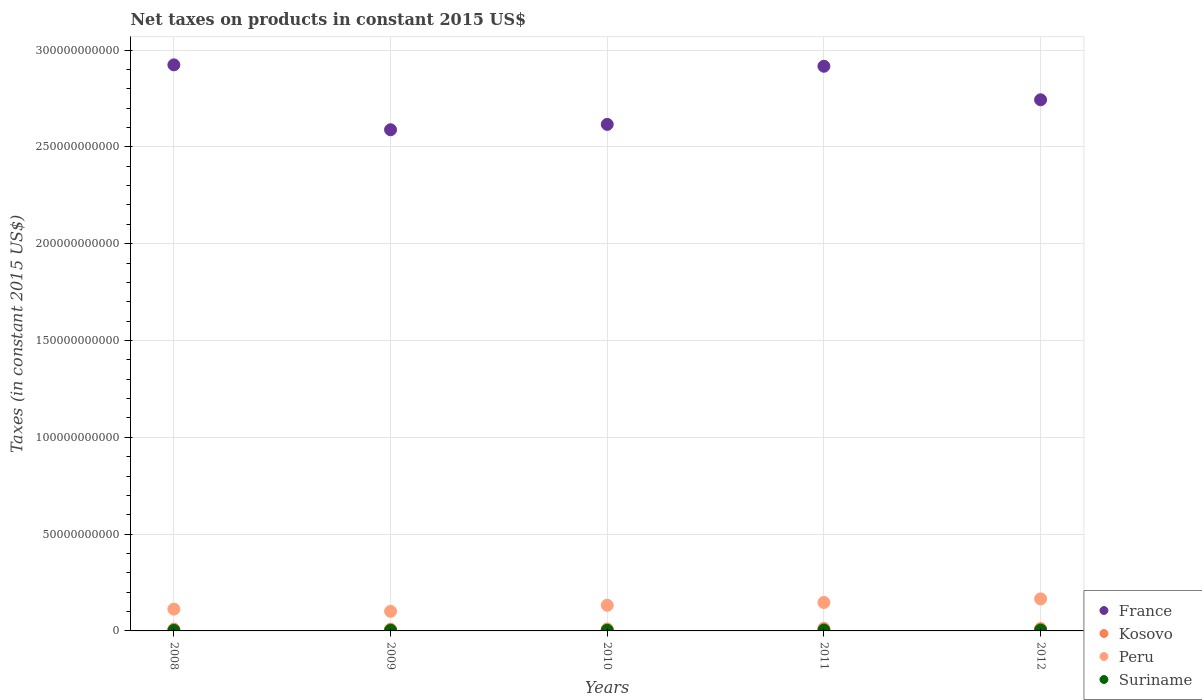How many different coloured dotlines are there?
Your answer should be compact. 4. Is the number of dotlines equal to the number of legend labels?
Your answer should be very brief. Yes. What is the net taxes on products in Kosovo in 2008?
Give a very brief answer. 8.66e+08. Across all years, what is the maximum net taxes on products in France?
Offer a very short reply. 2.92e+11. Across all years, what is the minimum net taxes on products in Kosovo?
Offer a very short reply. 8.48e+08. In which year was the net taxes on products in Peru maximum?
Provide a succinct answer. 2012. What is the total net taxes on products in Kosovo in the graph?
Your response must be concise. 5.02e+09. What is the difference between the net taxes on products in Suriname in 2010 and that in 2011?
Ensure brevity in your answer.  -9.22e+07. What is the difference between the net taxes on products in Peru in 2012 and the net taxes on products in France in 2009?
Ensure brevity in your answer.  -2.42e+11. What is the average net taxes on products in Suriname per year?
Your answer should be very brief. 3.41e+08. In the year 2012, what is the difference between the net taxes on products in Suriname and net taxes on products in Peru?
Provide a short and direct response. -1.61e+1. In how many years, is the net taxes on products in Peru greater than 130000000000 US$?
Offer a very short reply. 0. What is the ratio of the net taxes on products in Kosovo in 2008 to that in 2011?
Offer a terse response. 0.72. Is the net taxes on products in Suriname in 2009 less than that in 2011?
Make the answer very short. Yes. What is the difference between the highest and the second highest net taxes on products in Kosovo?
Ensure brevity in your answer.  6.31e+07. What is the difference between the highest and the lowest net taxes on products in Peru?
Offer a terse response. 6.41e+09. Is it the case that in every year, the sum of the net taxes on products in Peru and net taxes on products in France  is greater than the sum of net taxes on products in Suriname and net taxes on products in Kosovo?
Offer a terse response. Yes. Is it the case that in every year, the sum of the net taxes on products in Suriname and net taxes on products in Kosovo  is greater than the net taxes on products in Peru?
Provide a short and direct response. No. How many dotlines are there?
Your response must be concise. 4. How many years are there in the graph?
Offer a very short reply. 5. Does the graph contain any zero values?
Make the answer very short. No. What is the title of the graph?
Ensure brevity in your answer.  Net taxes on products in constant 2015 US$. Does "Guam" appear as one of the legend labels in the graph?
Ensure brevity in your answer.  No. What is the label or title of the Y-axis?
Your answer should be very brief. Taxes (in constant 2015 US$). What is the Taxes (in constant 2015 US$) in France in 2008?
Ensure brevity in your answer.  2.92e+11. What is the Taxes (in constant 2015 US$) in Kosovo in 2008?
Give a very brief answer. 8.66e+08. What is the Taxes (in constant 2015 US$) in Peru in 2008?
Give a very brief answer. 1.13e+1. What is the Taxes (in constant 2015 US$) in Suriname in 2008?
Provide a succinct answer. 2.41e+08. What is the Taxes (in constant 2015 US$) of France in 2009?
Ensure brevity in your answer.  2.59e+11. What is the Taxes (in constant 2015 US$) of Kosovo in 2009?
Provide a succinct answer. 8.48e+08. What is the Taxes (in constant 2015 US$) in Peru in 2009?
Give a very brief answer. 1.01e+1. What is the Taxes (in constant 2015 US$) in Suriname in 2009?
Your answer should be compact. 3.17e+08. What is the Taxes (in constant 2015 US$) of France in 2010?
Ensure brevity in your answer.  2.62e+11. What is the Taxes (in constant 2015 US$) of Kosovo in 2010?
Offer a terse response. 9.47e+08. What is the Taxes (in constant 2015 US$) in Peru in 2010?
Your response must be concise. 1.32e+1. What is the Taxes (in constant 2015 US$) of Suriname in 2010?
Your answer should be very brief. 3.11e+08. What is the Taxes (in constant 2015 US$) of France in 2011?
Your answer should be compact. 2.92e+11. What is the Taxes (in constant 2015 US$) in Kosovo in 2011?
Provide a succinct answer. 1.21e+09. What is the Taxes (in constant 2015 US$) of Peru in 2011?
Ensure brevity in your answer.  1.47e+1. What is the Taxes (in constant 2015 US$) of Suriname in 2011?
Ensure brevity in your answer.  4.04e+08. What is the Taxes (in constant 2015 US$) of France in 2012?
Provide a short and direct response. 2.74e+11. What is the Taxes (in constant 2015 US$) in Kosovo in 2012?
Your response must be concise. 1.15e+09. What is the Taxes (in constant 2015 US$) in Peru in 2012?
Ensure brevity in your answer.  1.65e+1. What is the Taxes (in constant 2015 US$) of Suriname in 2012?
Your response must be concise. 4.32e+08. Across all years, what is the maximum Taxes (in constant 2015 US$) in France?
Give a very brief answer. 2.92e+11. Across all years, what is the maximum Taxes (in constant 2015 US$) in Kosovo?
Offer a very short reply. 1.21e+09. Across all years, what is the maximum Taxes (in constant 2015 US$) of Peru?
Provide a short and direct response. 1.65e+1. Across all years, what is the maximum Taxes (in constant 2015 US$) in Suriname?
Provide a succinct answer. 4.32e+08. Across all years, what is the minimum Taxes (in constant 2015 US$) of France?
Give a very brief answer. 2.59e+11. Across all years, what is the minimum Taxes (in constant 2015 US$) in Kosovo?
Your answer should be compact. 8.48e+08. Across all years, what is the minimum Taxes (in constant 2015 US$) of Peru?
Make the answer very short. 1.01e+1. Across all years, what is the minimum Taxes (in constant 2015 US$) in Suriname?
Your answer should be compact. 2.41e+08. What is the total Taxes (in constant 2015 US$) in France in the graph?
Offer a terse response. 1.38e+12. What is the total Taxes (in constant 2015 US$) of Kosovo in the graph?
Your answer should be compact. 5.02e+09. What is the total Taxes (in constant 2015 US$) in Peru in the graph?
Keep it short and to the point. 6.59e+1. What is the total Taxes (in constant 2015 US$) in Suriname in the graph?
Your answer should be very brief. 1.70e+09. What is the difference between the Taxes (in constant 2015 US$) in France in 2008 and that in 2009?
Your answer should be compact. 3.35e+1. What is the difference between the Taxes (in constant 2015 US$) in Kosovo in 2008 and that in 2009?
Make the answer very short. 1.74e+07. What is the difference between the Taxes (in constant 2015 US$) of Peru in 2008 and that in 2009?
Ensure brevity in your answer.  1.13e+09. What is the difference between the Taxes (in constant 2015 US$) in Suriname in 2008 and that in 2009?
Ensure brevity in your answer.  -7.54e+07. What is the difference between the Taxes (in constant 2015 US$) in France in 2008 and that in 2010?
Your answer should be compact. 3.07e+1. What is the difference between the Taxes (in constant 2015 US$) in Kosovo in 2008 and that in 2010?
Provide a succinct answer. -8.11e+07. What is the difference between the Taxes (in constant 2015 US$) in Peru in 2008 and that in 2010?
Your response must be concise. -1.99e+09. What is the difference between the Taxes (in constant 2015 US$) in Suriname in 2008 and that in 2010?
Ensure brevity in your answer.  -7.03e+07. What is the difference between the Taxes (in constant 2015 US$) in France in 2008 and that in 2011?
Offer a terse response. 7.19e+08. What is the difference between the Taxes (in constant 2015 US$) of Kosovo in 2008 and that in 2011?
Provide a succinct answer. -3.43e+08. What is the difference between the Taxes (in constant 2015 US$) in Peru in 2008 and that in 2011?
Keep it short and to the point. -3.45e+09. What is the difference between the Taxes (in constant 2015 US$) in Suriname in 2008 and that in 2011?
Ensure brevity in your answer.  -1.62e+08. What is the difference between the Taxes (in constant 2015 US$) in France in 2008 and that in 2012?
Keep it short and to the point. 1.80e+1. What is the difference between the Taxes (in constant 2015 US$) in Kosovo in 2008 and that in 2012?
Your answer should be compact. -2.80e+08. What is the difference between the Taxes (in constant 2015 US$) of Peru in 2008 and that in 2012?
Your answer should be very brief. -5.29e+09. What is the difference between the Taxes (in constant 2015 US$) of Suriname in 2008 and that in 2012?
Make the answer very short. -1.91e+08. What is the difference between the Taxes (in constant 2015 US$) in France in 2009 and that in 2010?
Offer a very short reply. -2.77e+09. What is the difference between the Taxes (in constant 2015 US$) in Kosovo in 2009 and that in 2010?
Your response must be concise. -9.85e+07. What is the difference between the Taxes (in constant 2015 US$) of Peru in 2009 and that in 2010?
Provide a succinct answer. -3.11e+09. What is the difference between the Taxes (in constant 2015 US$) of Suriname in 2009 and that in 2010?
Make the answer very short. 5.15e+06. What is the difference between the Taxes (in constant 2015 US$) of France in 2009 and that in 2011?
Keep it short and to the point. -3.28e+1. What is the difference between the Taxes (in constant 2015 US$) of Kosovo in 2009 and that in 2011?
Ensure brevity in your answer.  -3.60e+08. What is the difference between the Taxes (in constant 2015 US$) in Peru in 2009 and that in 2011?
Offer a very short reply. -4.58e+09. What is the difference between the Taxes (in constant 2015 US$) of Suriname in 2009 and that in 2011?
Provide a succinct answer. -8.70e+07. What is the difference between the Taxes (in constant 2015 US$) in France in 2009 and that in 2012?
Make the answer very short. -1.55e+1. What is the difference between the Taxes (in constant 2015 US$) of Kosovo in 2009 and that in 2012?
Provide a short and direct response. -2.97e+08. What is the difference between the Taxes (in constant 2015 US$) in Peru in 2009 and that in 2012?
Make the answer very short. -6.41e+09. What is the difference between the Taxes (in constant 2015 US$) in Suriname in 2009 and that in 2012?
Offer a very short reply. -1.16e+08. What is the difference between the Taxes (in constant 2015 US$) in France in 2010 and that in 2011?
Your answer should be compact. -3.00e+1. What is the difference between the Taxes (in constant 2015 US$) in Kosovo in 2010 and that in 2011?
Your response must be concise. -2.62e+08. What is the difference between the Taxes (in constant 2015 US$) of Peru in 2010 and that in 2011?
Your answer should be compact. -1.47e+09. What is the difference between the Taxes (in constant 2015 US$) of Suriname in 2010 and that in 2011?
Ensure brevity in your answer.  -9.22e+07. What is the difference between the Taxes (in constant 2015 US$) in France in 2010 and that in 2012?
Give a very brief answer. -1.27e+1. What is the difference between the Taxes (in constant 2015 US$) in Kosovo in 2010 and that in 2012?
Your answer should be very brief. -1.99e+08. What is the difference between the Taxes (in constant 2015 US$) of Peru in 2010 and that in 2012?
Provide a short and direct response. -3.30e+09. What is the difference between the Taxes (in constant 2015 US$) of Suriname in 2010 and that in 2012?
Provide a succinct answer. -1.21e+08. What is the difference between the Taxes (in constant 2015 US$) of France in 2011 and that in 2012?
Ensure brevity in your answer.  1.73e+1. What is the difference between the Taxes (in constant 2015 US$) of Kosovo in 2011 and that in 2012?
Give a very brief answer. 6.31e+07. What is the difference between the Taxes (in constant 2015 US$) in Peru in 2011 and that in 2012?
Provide a succinct answer. -1.83e+09. What is the difference between the Taxes (in constant 2015 US$) in Suriname in 2011 and that in 2012?
Ensure brevity in your answer.  -2.85e+07. What is the difference between the Taxes (in constant 2015 US$) of France in 2008 and the Taxes (in constant 2015 US$) of Kosovo in 2009?
Your answer should be compact. 2.91e+11. What is the difference between the Taxes (in constant 2015 US$) of France in 2008 and the Taxes (in constant 2015 US$) of Peru in 2009?
Your answer should be compact. 2.82e+11. What is the difference between the Taxes (in constant 2015 US$) of France in 2008 and the Taxes (in constant 2015 US$) of Suriname in 2009?
Your answer should be compact. 2.92e+11. What is the difference between the Taxes (in constant 2015 US$) in Kosovo in 2008 and the Taxes (in constant 2015 US$) in Peru in 2009?
Your response must be concise. -9.26e+09. What is the difference between the Taxes (in constant 2015 US$) in Kosovo in 2008 and the Taxes (in constant 2015 US$) in Suriname in 2009?
Ensure brevity in your answer.  5.49e+08. What is the difference between the Taxes (in constant 2015 US$) of Peru in 2008 and the Taxes (in constant 2015 US$) of Suriname in 2009?
Your answer should be compact. 1.09e+1. What is the difference between the Taxes (in constant 2015 US$) in France in 2008 and the Taxes (in constant 2015 US$) in Kosovo in 2010?
Make the answer very short. 2.91e+11. What is the difference between the Taxes (in constant 2015 US$) of France in 2008 and the Taxes (in constant 2015 US$) of Peru in 2010?
Give a very brief answer. 2.79e+11. What is the difference between the Taxes (in constant 2015 US$) in France in 2008 and the Taxes (in constant 2015 US$) in Suriname in 2010?
Offer a terse response. 2.92e+11. What is the difference between the Taxes (in constant 2015 US$) in Kosovo in 2008 and the Taxes (in constant 2015 US$) in Peru in 2010?
Keep it short and to the point. -1.24e+1. What is the difference between the Taxes (in constant 2015 US$) of Kosovo in 2008 and the Taxes (in constant 2015 US$) of Suriname in 2010?
Provide a short and direct response. 5.54e+08. What is the difference between the Taxes (in constant 2015 US$) of Peru in 2008 and the Taxes (in constant 2015 US$) of Suriname in 2010?
Provide a short and direct response. 1.09e+1. What is the difference between the Taxes (in constant 2015 US$) in France in 2008 and the Taxes (in constant 2015 US$) in Kosovo in 2011?
Offer a very short reply. 2.91e+11. What is the difference between the Taxes (in constant 2015 US$) in France in 2008 and the Taxes (in constant 2015 US$) in Peru in 2011?
Your response must be concise. 2.78e+11. What is the difference between the Taxes (in constant 2015 US$) of France in 2008 and the Taxes (in constant 2015 US$) of Suriname in 2011?
Provide a short and direct response. 2.92e+11. What is the difference between the Taxes (in constant 2015 US$) of Kosovo in 2008 and the Taxes (in constant 2015 US$) of Peru in 2011?
Your response must be concise. -1.38e+1. What is the difference between the Taxes (in constant 2015 US$) in Kosovo in 2008 and the Taxes (in constant 2015 US$) in Suriname in 2011?
Offer a very short reply. 4.62e+08. What is the difference between the Taxes (in constant 2015 US$) of Peru in 2008 and the Taxes (in constant 2015 US$) of Suriname in 2011?
Provide a short and direct response. 1.08e+1. What is the difference between the Taxes (in constant 2015 US$) in France in 2008 and the Taxes (in constant 2015 US$) in Kosovo in 2012?
Offer a very short reply. 2.91e+11. What is the difference between the Taxes (in constant 2015 US$) of France in 2008 and the Taxes (in constant 2015 US$) of Peru in 2012?
Your answer should be compact. 2.76e+11. What is the difference between the Taxes (in constant 2015 US$) in France in 2008 and the Taxes (in constant 2015 US$) in Suriname in 2012?
Keep it short and to the point. 2.92e+11. What is the difference between the Taxes (in constant 2015 US$) of Kosovo in 2008 and the Taxes (in constant 2015 US$) of Peru in 2012?
Offer a terse response. -1.57e+1. What is the difference between the Taxes (in constant 2015 US$) in Kosovo in 2008 and the Taxes (in constant 2015 US$) in Suriname in 2012?
Ensure brevity in your answer.  4.34e+08. What is the difference between the Taxes (in constant 2015 US$) in Peru in 2008 and the Taxes (in constant 2015 US$) in Suriname in 2012?
Offer a very short reply. 1.08e+1. What is the difference between the Taxes (in constant 2015 US$) in France in 2009 and the Taxes (in constant 2015 US$) in Kosovo in 2010?
Offer a terse response. 2.58e+11. What is the difference between the Taxes (in constant 2015 US$) in France in 2009 and the Taxes (in constant 2015 US$) in Peru in 2010?
Your answer should be very brief. 2.46e+11. What is the difference between the Taxes (in constant 2015 US$) of France in 2009 and the Taxes (in constant 2015 US$) of Suriname in 2010?
Keep it short and to the point. 2.59e+11. What is the difference between the Taxes (in constant 2015 US$) of Kosovo in 2009 and the Taxes (in constant 2015 US$) of Peru in 2010?
Your response must be concise. -1.24e+1. What is the difference between the Taxes (in constant 2015 US$) of Kosovo in 2009 and the Taxes (in constant 2015 US$) of Suriname in 2010?
Provide a short and direct response. 5.37e+08. What is the difference between the Taxes (in constant 2015 US$) of Peru in 2009 and the Taxes (in constant 2015 US$) of Suriname in 2010?
Keep it short and to the point. 9.82e+09. What is the difference between the Taxes (in constant 2015 US$) in France in 2009 and the Taxes (in constant 2015 US$) in Kosovo in 2011?
Provide a succinct answer. 2.58e+11. What is the difference between the Taxes (in constant 2015 US$) in France in 2009 and the Taxes (in constant 2015 US$) in Peru in 2011?
Offer a terse response. 2.44e+11. What is the difference between the Taxes (in constant 2015 US$) of France in 2009 and the Taxes (in constant 2015 US$) of Suriname in 2011?
Provide a short and direct response. 2.58e+11. What is the difference between the Taxes (in constant 2015 US$) in Kosovo in 2009 and the Taxes (in constant 2015 US$) in Peru in 2011?
Make the answer very short. -1.39e+1. What is the difference between the Taxes (in constant 2015 US$) in Kosovo in 2009 and the Taxes (in constant 2015 US$) in Suriname in 2011?
Your response must be concise. 4.45e+08. What is the difference between the Taxes (in constant 2015 US$) of Peru in 2009 and the Taxes (in constant 2015 US$) of Suriname in 2011?
Offer a very short reply. 9.72e+09. What is the difference between the Taxes (in constant 2015 US$) in France in 2009 and the Taxes (in constant 2015 US$) in Kosovo in 2012?
Offer a very short reply. 2.58e+11. What is the difference between the Taxes (in constant 2015 US$) of France in 2009 and the Taxes (in constant 2015 US$) of Peru in 2012?
Your answer should be compact. 2.42e+11. What is the difference between the Taxes (in constant 2015 US$) in France in 2009 and the Taxes (in constant 2015 US$) in Suriname in 2012?
Your response must be concise. 2.58e+11. What is the difference between the Taxes (in constant 2015 US$) of Kosovo in 2009 and the Taxes (in constant 2015 US$) of Peru in 2012?
Give a very brief answer. -1.57e+1. What is the difference between the Taxes (in constant 2015 US$) of Kosovo in 2009 and the Taxes (in constant 2015 US$) of Suriname in 2012?
Provide a short and direct response. 4.16e+08. What is the difference between the Taxes (in constant 2015 US$) in Peru in 2009 and the Taxes (in constant 2015 US$) in Suriname in 2012?
Keep it short and to the point. 9.69e+09. What is the difference between the Taxes (in constant 2015 US$) of France in 2010 and the Taxes (in constant 2015 US$) of Kosovo in 2011?
Ensure brevity in your answer.  2.60e+11. What is the difference between the Taxes (in constant 2015 US$) in France in 2010 and the Taxes (in constant 2015 US$) in Peru in 2011?
Make the answer very short. 2.47e+11. What is the difference between the Taxes (in constant 2015 US$) of France in 2010 and the Taxes (in constant 2015 US$) of Suriname in 2011?
Make the answer very short. 2.61e+11. What is the difference between the Taxes (in constant 2015 US$) of Kosovo in 2010 and the Taxes (in constant 2015 US$) of Peru in 2011?
Your response must be concise. -1.38e+1. What is the difference between the Taxes (in constant 2015 US$) of Kosovo in 2010 and the Taxes (in constant 2015 US$) of Suriname in 2011?
Your answer should be very brief. 5.43e+08. What is the difference between the Taxes (in constant 2015 US$) in Peru in 2010 and the Taxes (in constant 2015 US$) in Suriname in 2011?
Your response must be concise. 1.28e+1. What is the difference between the Taxes (in constant 2015 US$) in France in 2010 and the Taxes (in constant 2015 US$) in Kosovo in 2012?
Your answer should be compact. 2.60e+11. What is the difference between the Taxes (in constant 2015 US$) in France in 2010 and the Taxes (in constant 2015 US$) in Peru in 2012?
Offer a very short reply. 2.45e+11. What is the difference between the Taxes (in constant 2015 US$) in France in 2010 and the Taxes (in constant 2015 US$) in Suriname in 2012?
Make the answer very short. 2.61e+11. What is the difference between the Taxes (in constant 2015 US$) of Kosovo in 2010 and the Taxes (in constant 2015 US$) of Peru in 2012?
Give a very brief answer. -1.56e+1. What is the difference between the Taxes (in constant 2015 US$) of Kosovo in 2010 and the Taxes (in constant 2015 US$) of Suriname in 2012?
Make the answer very short. 5.15e+08. What is the difference between the Taxes (in constant 2015 US$) of Peru in 2010 and the Taxes (in constant 2015 US$) of Suriname in 2012?
Your answer should be very brief. 1.28e+1. What is the difference between the Taxes (in constant 2015 US$) in France in 2011 and the Taxes (in constant 2015 US$) in Kosovo in 2012?
Your response must be concise. 2.90e+11. What is the difference between the Taxes (in constant 2015 US$) of France in 2011 and the Taxes (in constant 2015 US$) of Peru in 2012?
Offer a terse response. 2.75e+11. What is the difference between the Taxes (in constant 2015 US$) in France in 2011 and the Taxes (in constant 2015 US$) in Suriname in 2012?
Your answer should be very brief. 2.91e+11. What is the difference between the Taxes (in constant 2015 US$) of Kosovo in 2011 and the Taxes (in constant 2015 US$) of Peru in 2012?
Your answer should be very brief. -1.53e+1. What is the difference between the Taxes (in constant 2015 US$) of Kosovo in 2011 and the Taxes (in constant 2015 US$) of Suriname in 2012?
Ensure brevity in your answer.  7.77e+08. What is the difference between the Taxes (in constant 2015 US$) in Peru in 2011 and the Taxes (in constant 2015 US$) in Suriname in 2012?
Offer a terse response. 1.43e+1. What is the average Taxes (in constant 2015 US$) in France per year?
Keep it short and to the point. 2.76e+11. What is the average Taxes (in constant 2015 US$) of Kosovo per year?
Keep it short and to the point. 1.00e+09. What is the average Taxes (in constant 2015 US$) in Peru per year?
Provide a short and direct response. 1.32e+1. What is the average Taxes (in constant 2015 US$) in Suriname per year?
Offer a terse response. 3.41e+08. In the year 2008, what is the difference between the Taxes (in constant 2015 US$) in France and Taxes (in constant 2015 US$) in Kosovo?
Give a very brief answer. 2.91e+11. In the year 2008, what is the difference between the Taxes (in constant 2015 US$) of France and Taxes (in constant 2015 US$) of Peru?
Offer a very short reply. 2.81e+11. In the year 2008, what is the difference between the Taxes (in constant 2015 US$) in France and Taxes (in constant 2015 US$) in Suriname?
Your response must be concise. 2.92e+11. In the year 2008, what is the difference between the Taxes (in constant 2015 US$) in Kosovo and Taxes (in constant 2015 US$) in Peru?
Offer a terse response. -1.04e+1. In the year 2008, what is the difference between the Taxes (in constant 2015 US$) in Kosovo and Taxes (in constant 2015 US$) in Suriname?
Your response must be concise. 6.25e+08. In the year 2008, what is the difference between the Taxes (in constant 2015 US$) in Peru and Taxes (in constant 2015 US$) in Suriname?
Make the answer very short. 1.10e+1. In the year 2009, what is the difference between the Taxes (in constant 2015 US$) of France and Taxes (in constant 2015 US$) of Kosovo?
Your response must be concise. 2.58e+11. In the year 2009, what is the difference between the Taxes (in constant 2015 US$) in France and Taxes (in constant 2015 US$) in Peru?
Ensure brevity in your answer.  2.49e+11. In the year 2009, what is the difference between the Taxes (in constant 2015 US$) in France and Taxes (in constant 2015 US$) in Suriname?
Provide a short and direct response. 2.58e+11. In the year 2009, what is the difference between the Taxes (in constant 2015 US$) of Kosovo and Taxes (in constant 2015 US$) of Peru?
Make the answer very short. -9.28e+09. In the year 2009, what is the difference between the Taxes (in constant 2015 US$) of Kosovo and Taxes (in constant 2015 US$) of Suriname?
Your answer should be very brief. 5.32e+08. In the year 2009, what is the difference between the Taxes (in constant 2015 US$) of Peru and Taxes (in constant 2015 US$) of Suriname?
Offer a very short reply. 9.81e+09. In the year 2010, what is the difference between the Taxes (in constant 2015 US$) of France and Taxes (in constant 2015 US$) of Kosovo?
Your answer should be compact. 2.61e+11. In the year 2010, what is the difference between the Taxes (in constant 2015 US$) of France and Taxes (in constant 2015 US$) of Peru?
Provide a short and direct response. 2.48e+11. In the year 2010, what is the difference between the Taxes (in constant 2015 US$) in France and Taxes (in constant 2015 US$) in Suriname?
Your response must be concise. 2.61e+11. In the year 2010, what is the difference between the Taxes (in constant 2015 US$) of Kosovo and Taxes (in constant 2015 US$) of Peru?
Your response must be concise. -1.23e+1. In the year 2010, what is the difference between the Taxes (in constant 2015 US$) in Kosovo and Taxes (in constant 2015 US$) in Suriname?
Your response must be concise. 6.35e+08. In the year 2010, what is the difference between the Taxes (in constant 2015 US$) in Peru and Taxes (in constant 2015 US$) in Suriname?
Give a very brief answer. 1.29e+1. In the year 2011, what is the difference between the Taxes (in constant 2015 US$) of France and Taxes (in constant 2015 US$) of Kosovo?
Provide a short and direct response. 2.90e+11. In the year 2011, what is the difference between the Taxes (in constant 2015 US$) of France and Taxes (in constant 2015 US$) of Peru?
Your response must be concise. 2.77e+11. In the year 2011, what is the difference between the Taxes (in constant 2015 US$) in France and Taxes (in constant 2015 US$) in Suriname?
Provide a succinct answer. 2.91e+11. In the year 2011, what is the difference between the Taxes (in constant 2015 US$) in Kosovo and Taxes (in constant 2015 US$) in Peru?
Ensure brevity in your answer.  -1.35e+1. In the year 2011, what is the difference between the Taxes (in constant 2015 US$) of Kosovo and Taxes (in constant 2015 US$) of Suriname?
Ensure brevity in your answer.  8.05e+08. In the year 2011, what is the difference between the Taxes (in constant 2015 US$) of Peru and Taxes (in constant 2015 US$) of Suriname?
Provide a succinct answer. 1.43e+1. In the year 2012, what is the difference between the Taxes (in constant 2015 US$) of France and Taxes (in constant 2015 US$) of Kosovo?
Make the answer very short. 2.73e+11. In the year 2012, what is the difference between the Taxes (in constant 2015 US$) in France and Taxes (in constant 2015 US$) in Peru?
Provide a short and direct response. 2.58e+11. In the year 2012, what is the difference between the Taxes (in constant 2015 US$) of France and Taxes (in constant 2015 US$) of Suriname?
Your answer should be compact. 2.74e+11. In the year 2012, what is the difference between the Taxes (in constant 2015 US$) in Kosovo and Taxes (in constant 2015 US$) in Peru?
Offer a terse response. -1.54e+1. In the year 2012, what is the difference between the Taxes (in constant 2015 US$) of Kosovo and Taxes (in constant 2015 US$) of Suriname?
Offer a very short reply. 7.14e+08. In the year 2012, what is the difference between the Taxes (in constant 2015 US$) of Peru and Taxes (in constant 2015 US$) of Suriname?
Offer a very short reply. 1.61e+1. What is the ratio of the Taxes (in constant 2015 US$) of France in 2008 to that in 2009?
Your answer should be compact. 1.13. What is the ratio of the Taxes (in constant 2015 US$) in Kosovo in 2008 to that in 2009?
Offer a very short reply. 1.02. What is the ratio of the Taxes (in constant 2015 US$) of Suriname in 2008 to that in 2009?
Provide a short and direct response. 0.76. What is the ratio of the Taxes (in constant 2015 US$) in France in 2008 to that in 2010?
Your answer should be compact. 1.12. What is the ratio of the Taxes (in constant 2015 US$) of Kosovo in 2008 to that in 2010?
Ensure brevity in your answer.  0.91. What is the ratio of the Taxes (in constant 2015 US$) of Peru in 2008 to that in 2010?
Ensure brevity in your answer.  0.85. What is the ratio of the Taxes (in constant 2015 US$) in Suriname in 2008 to that in 2010?
Provide a succinct answer. 0.77. What is the ratio of the Taxes (in constant 2015 US$) of Kosovo in 2008 to that in 2011?
Make the answer very short. 0.72. What is the ratio of the Taxes (in constant 2015 US$) in Peru in 2008 to that in 2011?
Ensure brevity in your answer.  0.77. What is the ratio of the Taxes (in constant 2015 US$) of Suriname in 2008 to that in 2011?
Ensure brevity in your answer.  0.6. What is the ratio of the Taxes (in constant 2015 US$) in France in 2008 to that in 2012?
Your answer should be very brief. 1.07. What is the ratio of the Taxes (in constant 2015 US$) of Kosovo in 2008 to that in 2012?
Make the answer very short. 0.76. What is the ratio of the Taxes (in constant 2015 US$) in Peru in 2008 to that in 2012?
Make the answer very short. 0.68. What is the ratio of the Taxes (in constant 2015 US$) in Suriname in 2008 to that in 2012?
Keep it short and to the point. 0.56. What is the ratio of the Taxes (in constant 2015 US$) of Kosovo in 2009 to that in 2010?
Your response must be concise. 0.9. What is the ratio of the Taxes (in constant 2015 US$) of Peru in 2009 to that in 2010?
Give a very brief answer. 0.77. What is the ratio of the Taxes (in constant 2015 US$) in Suriname in 2009 to that in 2010?
Keep it short and to the point. 1.02. What is the ratio of the Taxes (in constant 2015 US$) in France in 2009 to that in 2011?
Your response must be concise. 0.89. What is the ratio of the Taxes (in constant 2015 US$) of Kosovo in 2009 to that in 2011?
Keep it short and to the point. 0.7. What is the ratio of the Taxes (in constant 2015 US$) of Peru in 2009 to that in 2011?
Keep it short and to the point. 0.69. What is the ratio of the Taxes (in constant 2015 US$) in Suriname in 2009 to that in 2011?
Provide a short and direct response. 0.78. What is the ratio of the Taxes (in constant 2015 US$) of France in 2009 to that in 2012?
Make the answer very short. 0.94. What is the ratio of the Taxes (in constant 2015 US$) in Kosovo in 2009 to that in 2012?
Make the answer very short. 0.74. What is the ratio of the Taxes (in constant 2015 US$) of Peru in 2009 to that in 2012?
Offer a very short reply. 0.61. What is the ratio of the Taxes (in constant 2015 US$) in Suriname in 2009 to that in 2012?
Your answer should be compact. 0.73. What is the ratio of the Taxes (in constant 2015 US$) in France in 2010 to that in 2011?
Offer a terse response. 0.9. What is the ratio of the Taxes (in constant 2015 US$) in Kosovo in 2010 to that in 2011?
Your response must be concise. 0.78. What is the ratio of the Taxes (in constant 2015 US$) in Peru in 2010 to that in 2011?
Your answer should be very brief. 0.9. What is the ratio of the Taxes (in constant 2015 US$) of Suriname in 2010 to that in 2011?
Offer a very short reply. 0.77. What is the ratio of the Taxes (in constant 2015 US$) of France in 2010 to that in 2012?
Keep it short and to the point. 0.95. What is the ratio of the Taxes (in constant 2015 US$) of Kosovo in 2010 to that in 2012?
Offer a very short reply. 0.83. What is the ratio of the Taxes (in constant 2015 US$) in Peru in 2010 to that in 2012?
Keep it short and to the point. 0.8. What is the ratio of the Taxes (in constant 2015 US$) in Suriname in 2010 to that in 2012?
Provide a succinct answer. 0.72. What is the ratio of the Taxes (in constant 2015 US$) in France in 2011 to that in 2012?
Your answer should be very brief. 1.06. What is the ratio of the Taxes (in constant 2015 US$) of Kosovo in 2011 to that in 2012?
Give a very brief answer. 1.06. What is the ratio of the Taxes (in constant 2015 US$) in Peru in 2011 to that in 2012?
Your answer should be very brief. 0.89. What is the ratio of the Taxes (in constant 2015 US$) in Suriname in 2011 to that in 2012?
Your answer should be very brief. 0.93. What is the difference between the highest and the second highest Taxes (in constant 2015 US$) in France?
Give a very brief answer. 7.19e+08. What is the difference between the highest and the second highest Taxes (in constant 2015 US$) of Kosovo?
Your answer should be compact. 6.31e+07. What is the difference between the highest and the second highest Taxes (in constant 2015 US$) of Peru?
Your answer should be very brief. 1.83e+09. What is the difference between the highest and the second highest Taxes (in constant 2015 US$) in Suriname?
Your answer should be compact. 2.85e+07. What is the difference between the highest and the lowest Taxes (in constant 2015 US$) of France?
Provide a succinct answer. 3.35e+1. What is the difference between the highest and the lowest Taxes (in constant 2015 US$) in Kosovo?
Keep it short and to the point. 3.60e+08. What is the difference between the highest and the lowest Taxes (in constant 2015 US$) of Peru?
Your response must be concise. 6.41e+09. What is the difference between the highest and the lowest Taxes (in constant 2015 US$) of Suriname?
Give a very brief answer. 1.91e+08. 